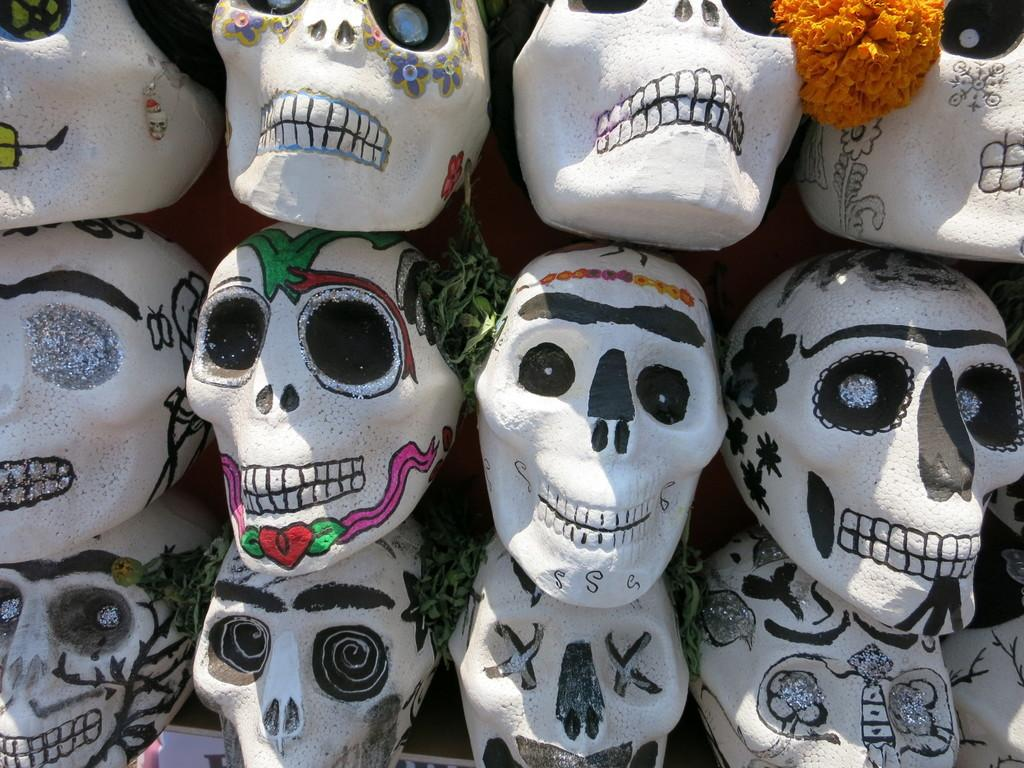What type of objects with a specific shape can be seen in the image? There are objects with the shape of a skull in the image. What type of plant is present in the image? There is a flower in the image. What type of vegetation is also visible in the image? There are leaves in the image. How many airplanes can be seen flying in the image? There are no airplanes visible in the image. What type of animals are interacting with the skull-shaped objects in the image? There are no animals present in the image. 